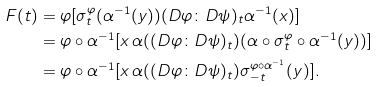Convert formula to latex. <formula><loc_0><loc_0><loc_500><loc_500>F ( t ) & = \varphi [ \sigma _ { t } ^ { \varphi } ( \alpha ^ { - 1 } ( y ) ) ( D \varphi \colon D \psi ) _ { t } \alpha ^ { - 1 } ( x ) ] \\ & = \varphi \circ \alpha ^ { - 1 } [ x \, \alpha ( ( D \varphi \colon D \psi ) _ { t } ) ( \alpha \circ \sigma _ { t } ^ { \varphi } \circ \alpha ^ { - 1 } ( y ) ) ] \\ & = \varphi \circ \alpha ^ { - 1 } [ x \, \alpha ( ( D \varphi \colon D \psi ) _ { t } ) \sigma _ { - t } ^ { \varphi \circ \alpha ^ { - 1 } } ( y ) ] .</formula> 